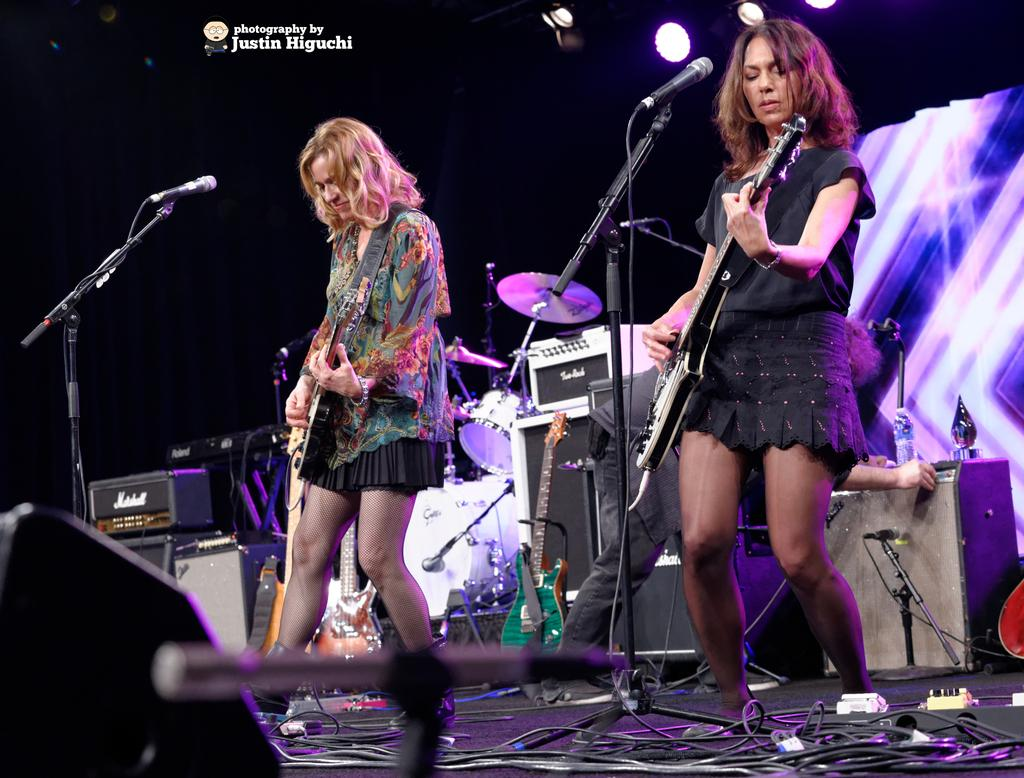How many people are in the image? There are 2 people in the image. What are the people doing in the image? The people are playing guitar. What object is in front of the people? There is a microphone in front of the people. Can you describe the posture of one of the people? There is a person bending at the back. What musical instrument can be seen at the back of the image? There are drums visible at the back. What type of icicle can be seen hanging from the guitar in the image? There is no icicle present in the image, and the guitar is not depicted as having any icicles hanging from it. 